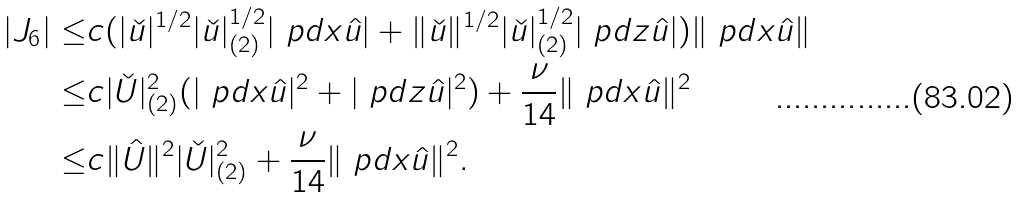Convert formula to latex. <formula><loc_0><loc_0><loc_500><loc_500>| J _ { 6 } | \leq & c ( | \check { u } | ^ { 1 / 2 } | \check { u } | _ { ( 2 ) } ^ { 1 / 2 } | \ p d { x } \hat { u } | + \| \check { u } \| ^ { 1 / 2 } | \check { u } | _ { ( 2 ) } ^ { 1 / 2 } | \ p d { z } \hat { u } | ) \| \ p d { x } \hat { u } \| \\ \leq & c | \check { U } | _ { ( 2 ) } ^ { 2 } ( | \ p d { x } \hat { u } | ^ { 2 } + | \ p d { z } \hat { u } | ^ { 2 } ) + \frac { \nu } { 1 4 } \| \ p d { x } \hat { u } \| ^ { 2 } \\ \leq & c \| \hat { U } \| ^ { 2 } | \check { U } | ^ { 2 } _ { ( 2 ) } + \frac { \nu } { 1 4 } \| \ p d { x } \hat { u } \| ^ { 2 } . \\</formula> 